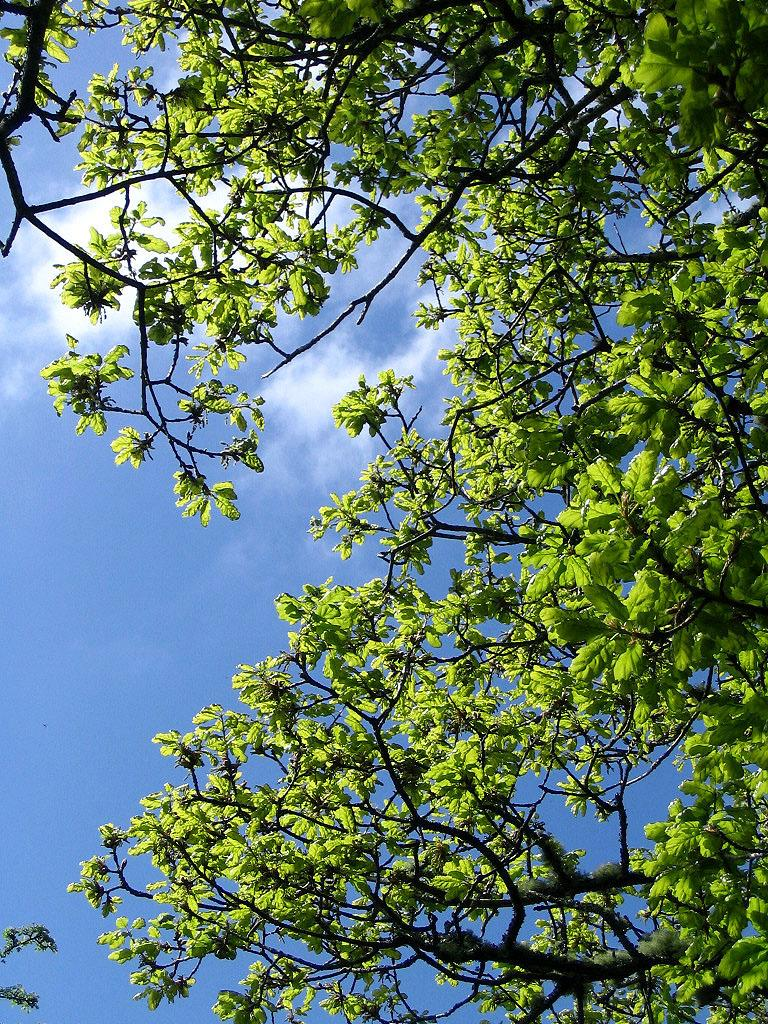What type of vegetation can be seen in the image? There are branches and leaves in the image. What is visible in the background of the image? There is sky visible in the background of the image. What can be seen in the sky in the image? Clouds are present in the sky. How many donkeys are visible in the image? There are no donkeys present in the image. What type of fowl can be seen in the image? There is no fowl present in the image. 